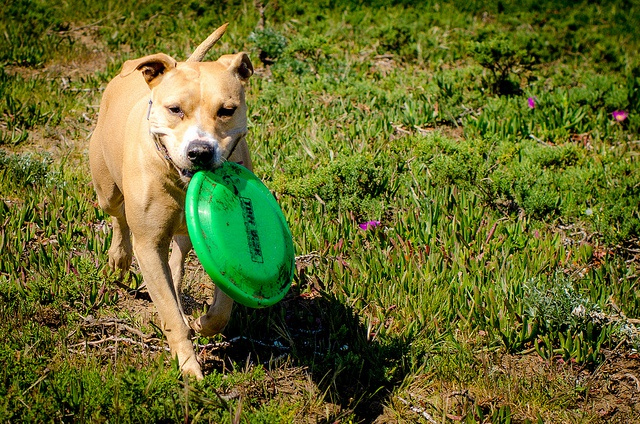Describe the objects in this image and their specific colors. I can see dog in darkgreen, tan, green, and black tones and frisbee in darkgreen, green, and lightgreen tones in this image. 